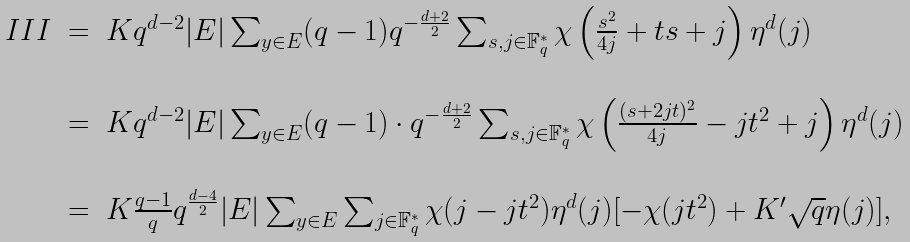Convert formula to latex. <formula><loc_0><loc_0><loc_500><loc_500>\begin{array} { l l l } I I I & = & K q ^ { d - 2 } | E | \sum _ { y \in E } ( q - 1 ) q ^ { - \frac { d + 2 } { 2 } } \sum _ { s , j \in { \mathbb { F } } _ { q } ^ { * } } \chi \left ( \frac { s ^ { 2 } } { 4 j } + t s + j \right ) \eta ^ { d } ( j ) \\ \\ & = & K q ^ { d - 2 } | E | \sum _ { y \in E } ( q - 1 ) \cdot q ^ { - \frac { d + 2 } { 2 } } \sum _ { s , j \in { \mathbb { F } } _ { q } ^ { * } } \chi \left ( \frac { ( s + 2 j t ) ^ { 2 } } { 4 j } - j t ^ { 2 } + j \right ) \eta ^ { d } ( j ) \\ \\ & = & K \frac { q - 1 } { q } q ^ { \frac { d - 4 } { 2 } } | E | \sum _ { y \in E } \sum _ { j \in { \mathbb { F } } _ { q } ^ { * } } \chi ( j - j t ^ { 2 } ) \eta ^ { d } ( j ) [ - \chi ( j t ^ { 2 } ) + K ^ { \prime } \sqrt { q } \eta ( j ) ] , \end{array}</formula> 